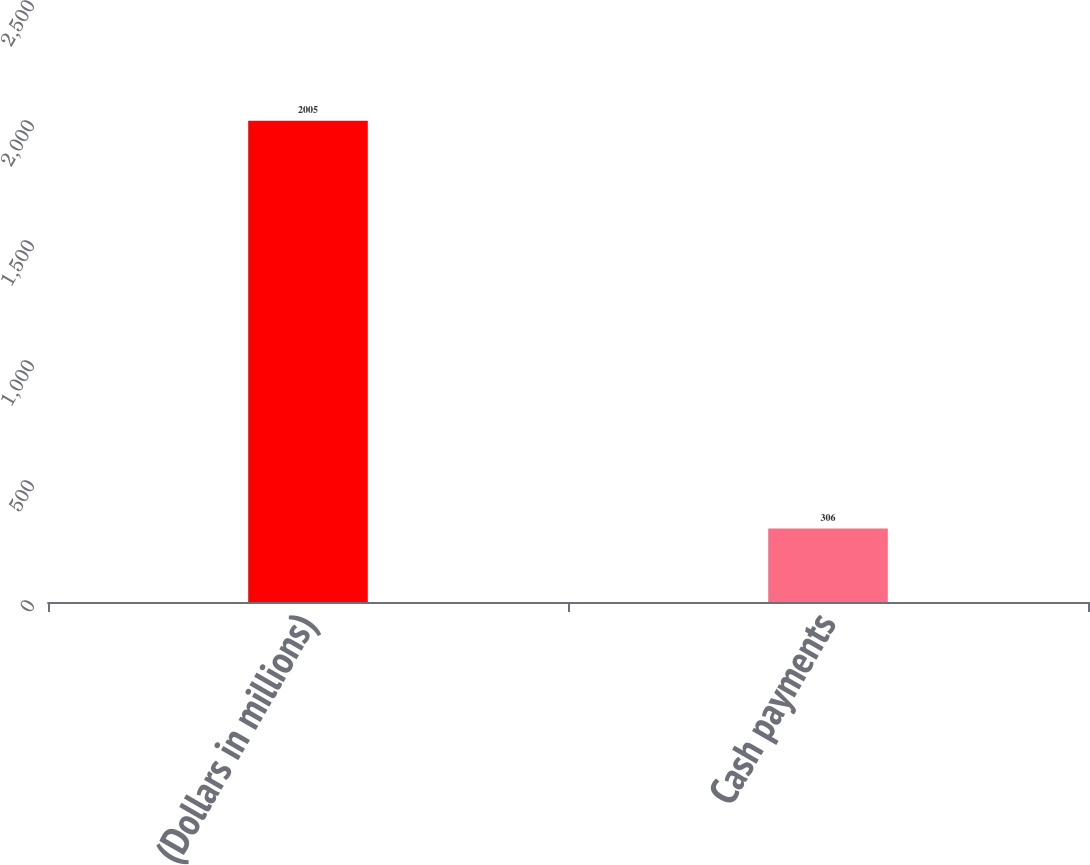Convert chart to OTSL. <chart><loc_0><loc_0><loc_500><loc_500><bar_chart><fcel>(Dollars in millions)<fcel>Cash payments<nl><fcel>2005<fcel>306<nl></chart> 